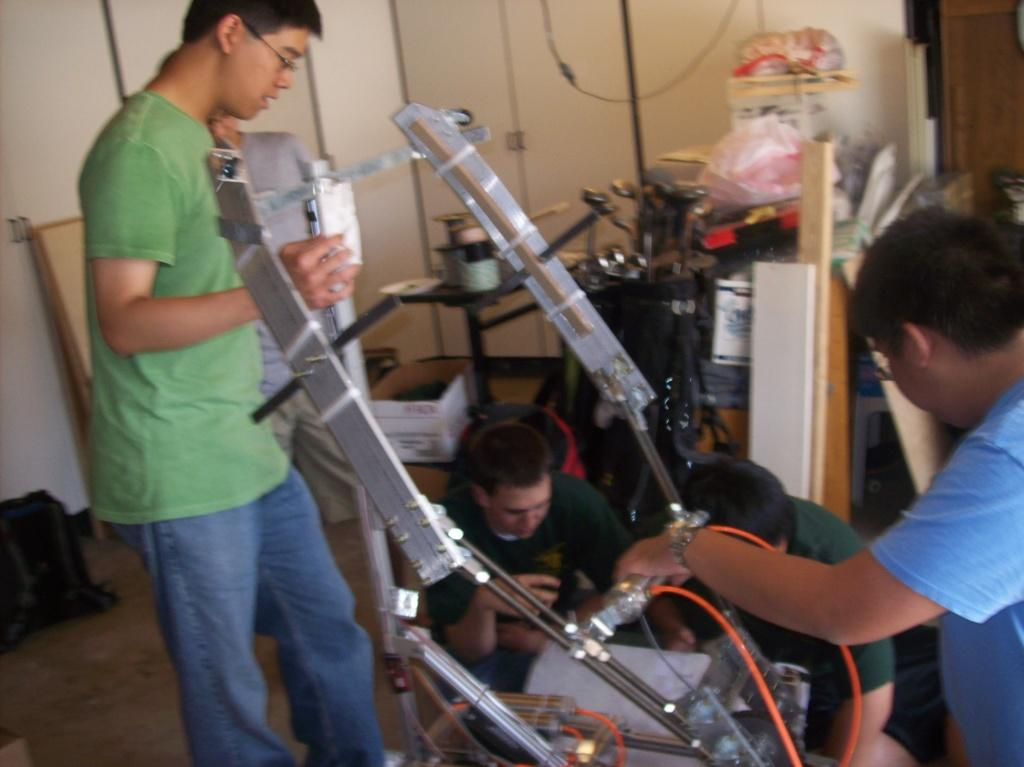Who or what is present in the image? There are people in the image. What can be seen on the floor in the image? There are objects on the floor in the image. What is visible in the background of the image? There is a wall in the background of the image. What type of yarn is being used to create the canvas in the image? There is no canvas or yarn present in the image. 